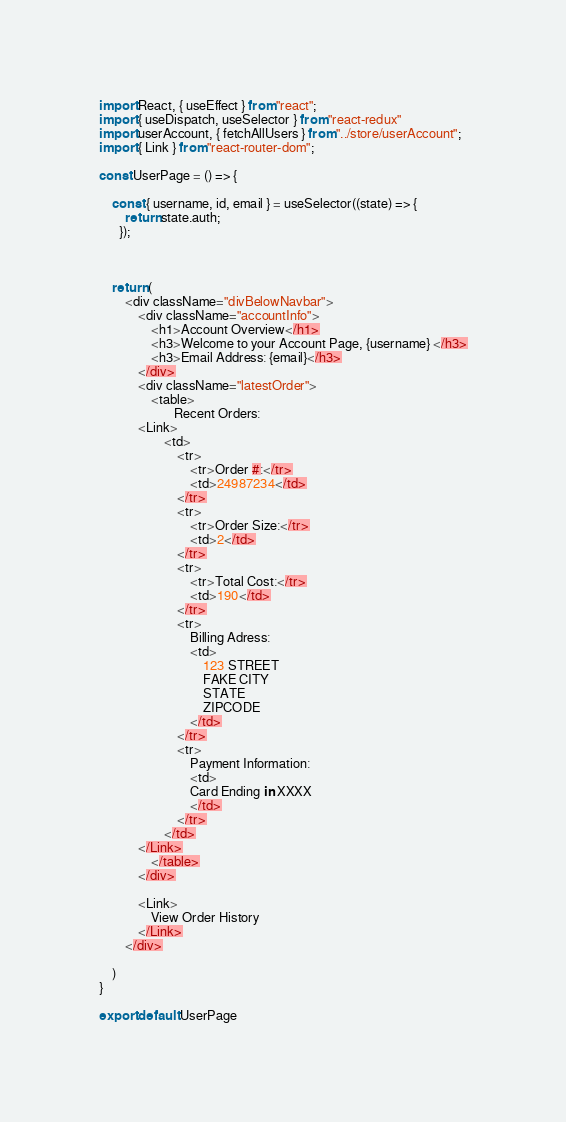Convert code to text. <code><loc_0><loc_0><loc_500><loc_500><_JavaScript_>import React, { useEffect } from "react";
import { useDispatch, useSelector } from "react-redux"
import userAccount, { fetchAllUsers } from "../store/userAccount";
import { Link } from "react-router-dom";

const UserPage = () => {

    const { username, id, email } = useSelector((state) => {
        return state.auth;
      });
      


    return (
        <div className="divBelowNavbar">
            <div className="accountInfo">
                <h1>Account Overview</h1>
                <h3>Welcome to your Account Page, {username} </h3>
                <h3>Email Address: {email}</h3>
            </div>
            <div className="latestOrder">
                <table>
                       Recent Orders:
            <Link>
                    <td>
                        <tr>
                            <tr>Order #:</tr>
                            <td>24987234</td>
                        </tr>
                        <tr>
                            <tr>Order Size:</tr>
                            <td>2</td>
                        </tr>
                        <tr>
                            <tr>Total Cost:</tr>
                            <td>190</td>
                        </tr>
                        <tr>
                            Billing Adress:
                            <td>
                                123 STREET
                                FAKE CITY
                                STATE
                                ZIPCODE
                            </td>
                        </tr>
                        <tr>
                            Payment Information:
                            <td>
                            Card Ending in XXXX
                            </td>
                        </tr>
                    </td>
            </Link>
                </table>
            </div>

            <Link>
                View Order History
            </Link>
        </div>
        
    )
}

export default UserPage</code> 